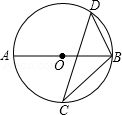Assuming that we know the length of the diameter, AB, could we find the exact length of CD using the principles of geometry depicted in the image? Indeed, if the diameter, AB, is known, one can find the length of chord CD by applying geometric principles. Given the relationship between angles and chords in a circle, we could use the Law of Sines or trigonometric identities in triangle ACD or BCD to compute the length of CD. The specific method would depend on available measurements besides the diameter. 